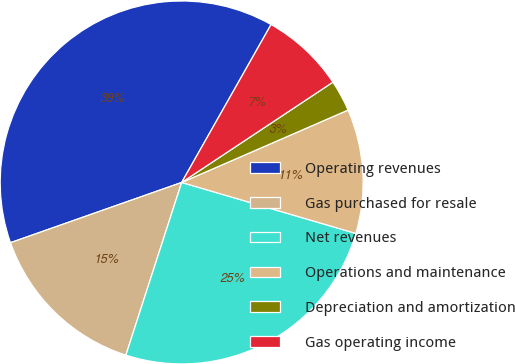Convert chart. <chart><loc_0><loc_0><loc_500><loc_500><pie_chart><fcel>Operating revenues<fcel>Gas purchased for resale<fcel>Net revenues<fcel>Operations and maintenance<fcel>Depreciation and amortization<fcel>Gas operating income<nl><fcel>38.58%<fcel>14.64%<fcel>25.44%<fcel>11.06%<fcel>2.79%<fcel>7.48%<nl></chart> 